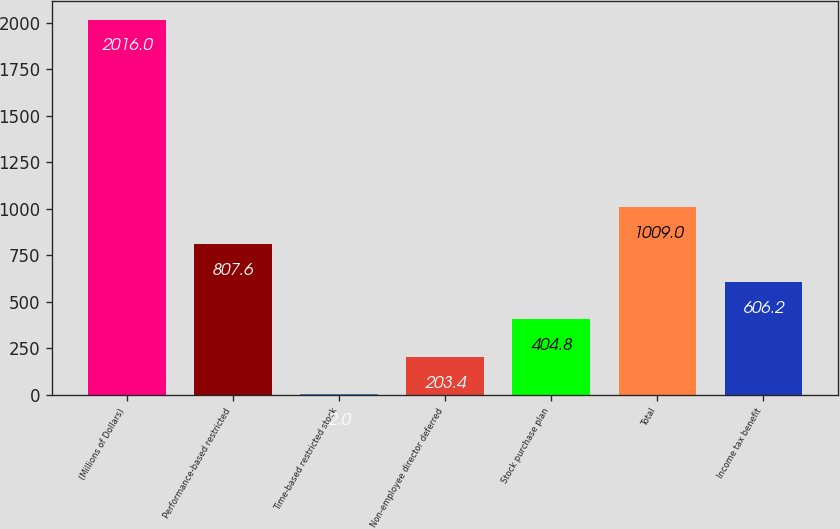<chart> <loc_0><loc_0><loc_500><loc_500><bar_chart><fcel>(Millions of Dollars)<fcel>Performance-based restricted<fcel>Time-based restricted stock<fcel>Non-employee director deferred<fcel>Stock purchase plan<fcel>Total<fcel>Income tax benefit<nl><fcel>2016<fcel>807.6<fcel>2<fcel>203.4<fcel>404.8<fcel>1009<fcel>606.2<nl></chart> 